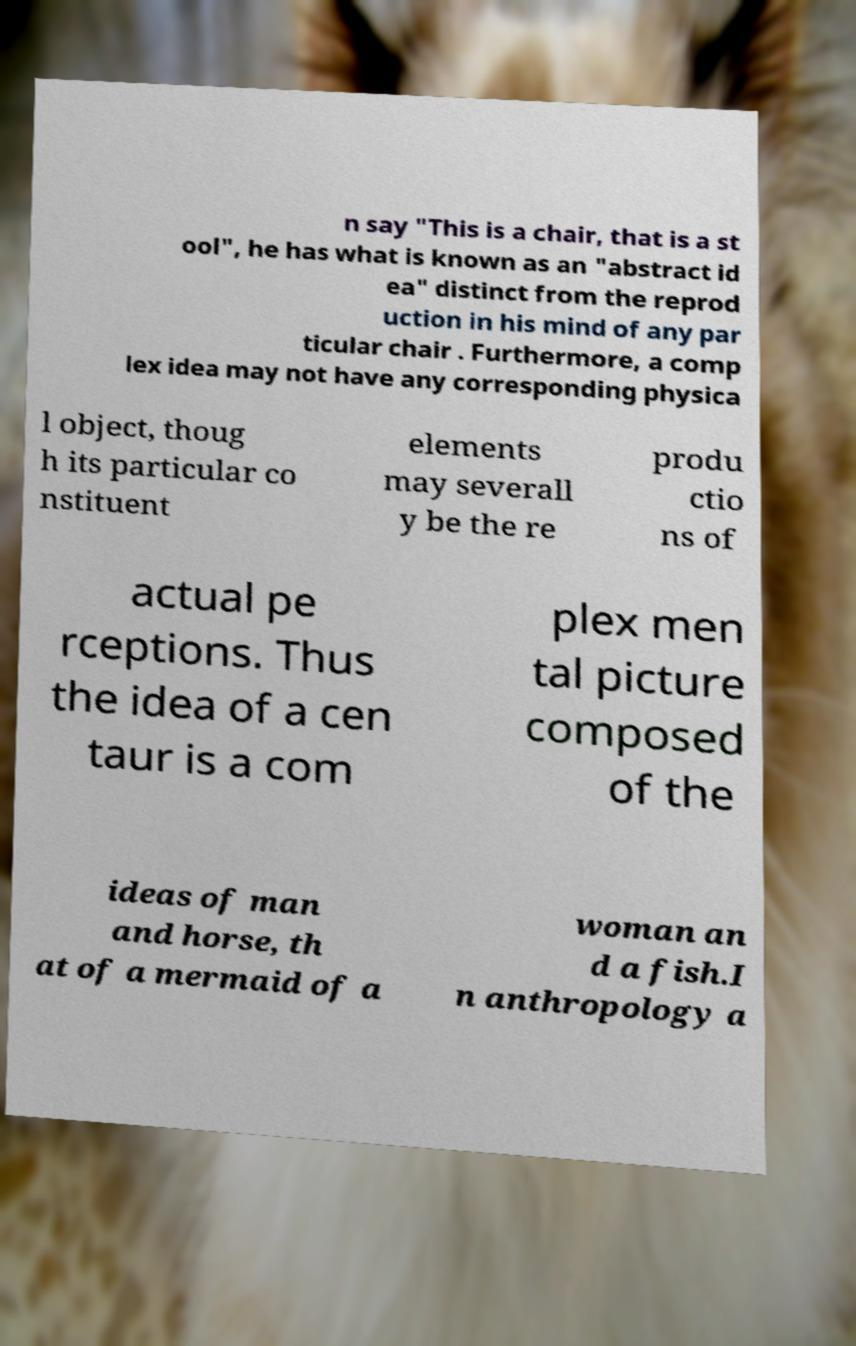Can you read and provide the text displayed in the image?This photo seems to have some interesting text. Can you extract and type it out for me? n say "This is a chair, that is a st ool", he has what is known as an "abstract id ea" distinct from the reprod uction in his mind of any par ticular chair . Furthermore, a comp lex idea may not have any corresponding physica l object, thoug h its particular co nstituent elements may severall y be the re produ ctio ns of actual pe rceptions. Thus the idea of a cen taur is a com plex men tal picture composed of the ideas of man and horse, th at of a mermaid of a woman an d a fish.I n anthropology a 